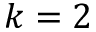<formula> <loc_0><loc_0><loc_500><loc_500>k = 2</formula> 